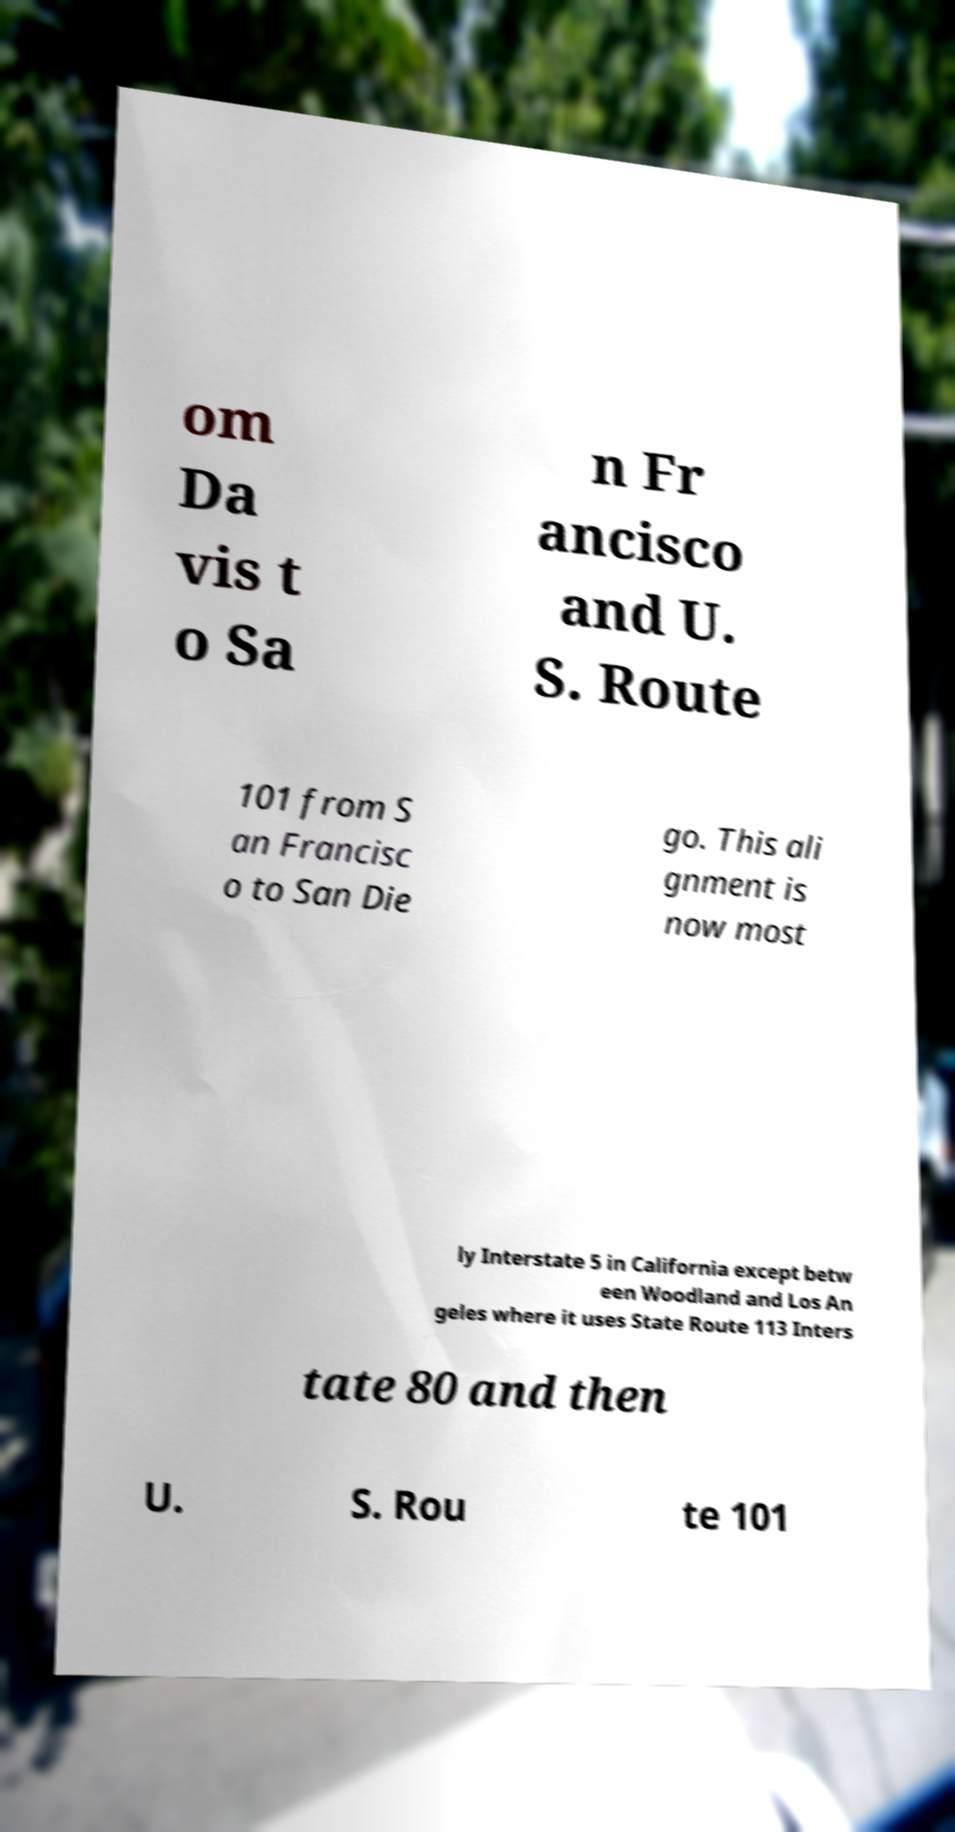Please read and relay the text visible in this image. What does it say? om Da vis t o Sa n Fr ancisco and U. S. Route 101 from S an Francisc o to San Die go. This ali gnment is now most ly Interstate 5 in California except betw een Woodland and Los An geles where it uses State Route 113 Inters tate 80 and then U. S. Rou te 101 